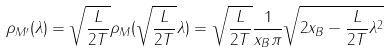<formula> <loc_0><loc_0><loc_500><loc_500>\rho _ { M ^ { \prime } } ( \lambda ) = \sqrt { \frac { L } { 2 T } } \rho _ { M } ( \sqrt { \frac { L } { 2 T } } \lambda ) = \sqrt { \frac { L } { 2 T } } \frac { 1 } { x _ { B } \pi } \sqrt { 2 x _ { B } - \frac { L } { 2 T } \lambda ^ { 2 } }</formula> 